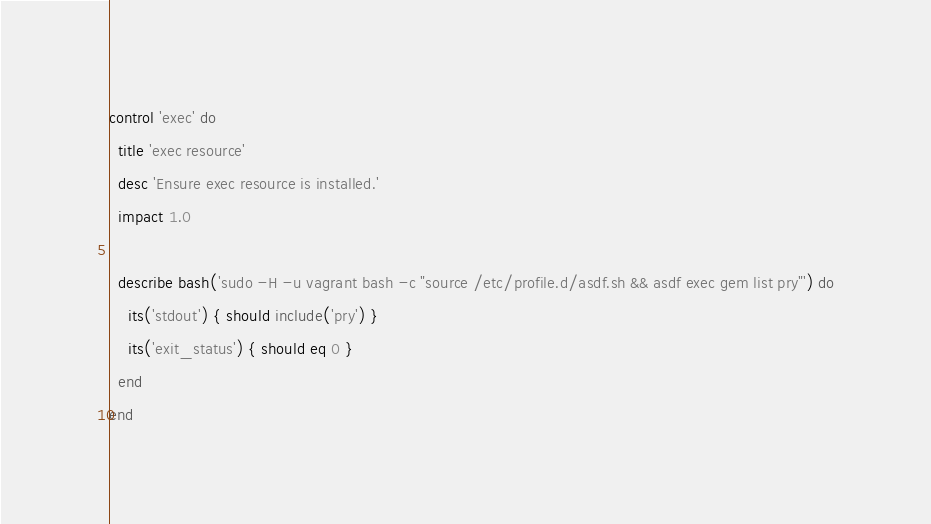<code> <loc_0><loc_0><loc_500><loc_500><_Ruby_>control 'exec' do
  title 'exec resource'
  desc 'Ensure exec resource is installed.'
  impact 1.0

  describe bash('sudo -H -u vagrant bash -c "source /etc/profile.d/asdf.sh && asdf exec gem list pry"') do
    its('stdout') { should include('pry') }
    its('exit_status') { should eq 0 }
  end
end
</code> 